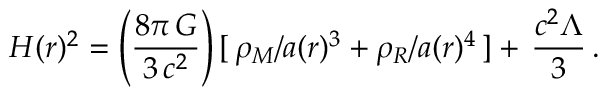<formula> <loc_0><loc_0><loc_500><loc_500>H ( r ) ^ { 2 } = \left ( \frac { 8 \pi \, G } { 3 \, c ^ { 2 } } \right ) [ \, \rho _ { M } / a ( r ) ^ { 3 } + \rho _ { R } / a ( r ) ^ { 4 } \, ] + \, \frac { c ^ { 2 } \Lambda } { 3 } \, .</formula> 